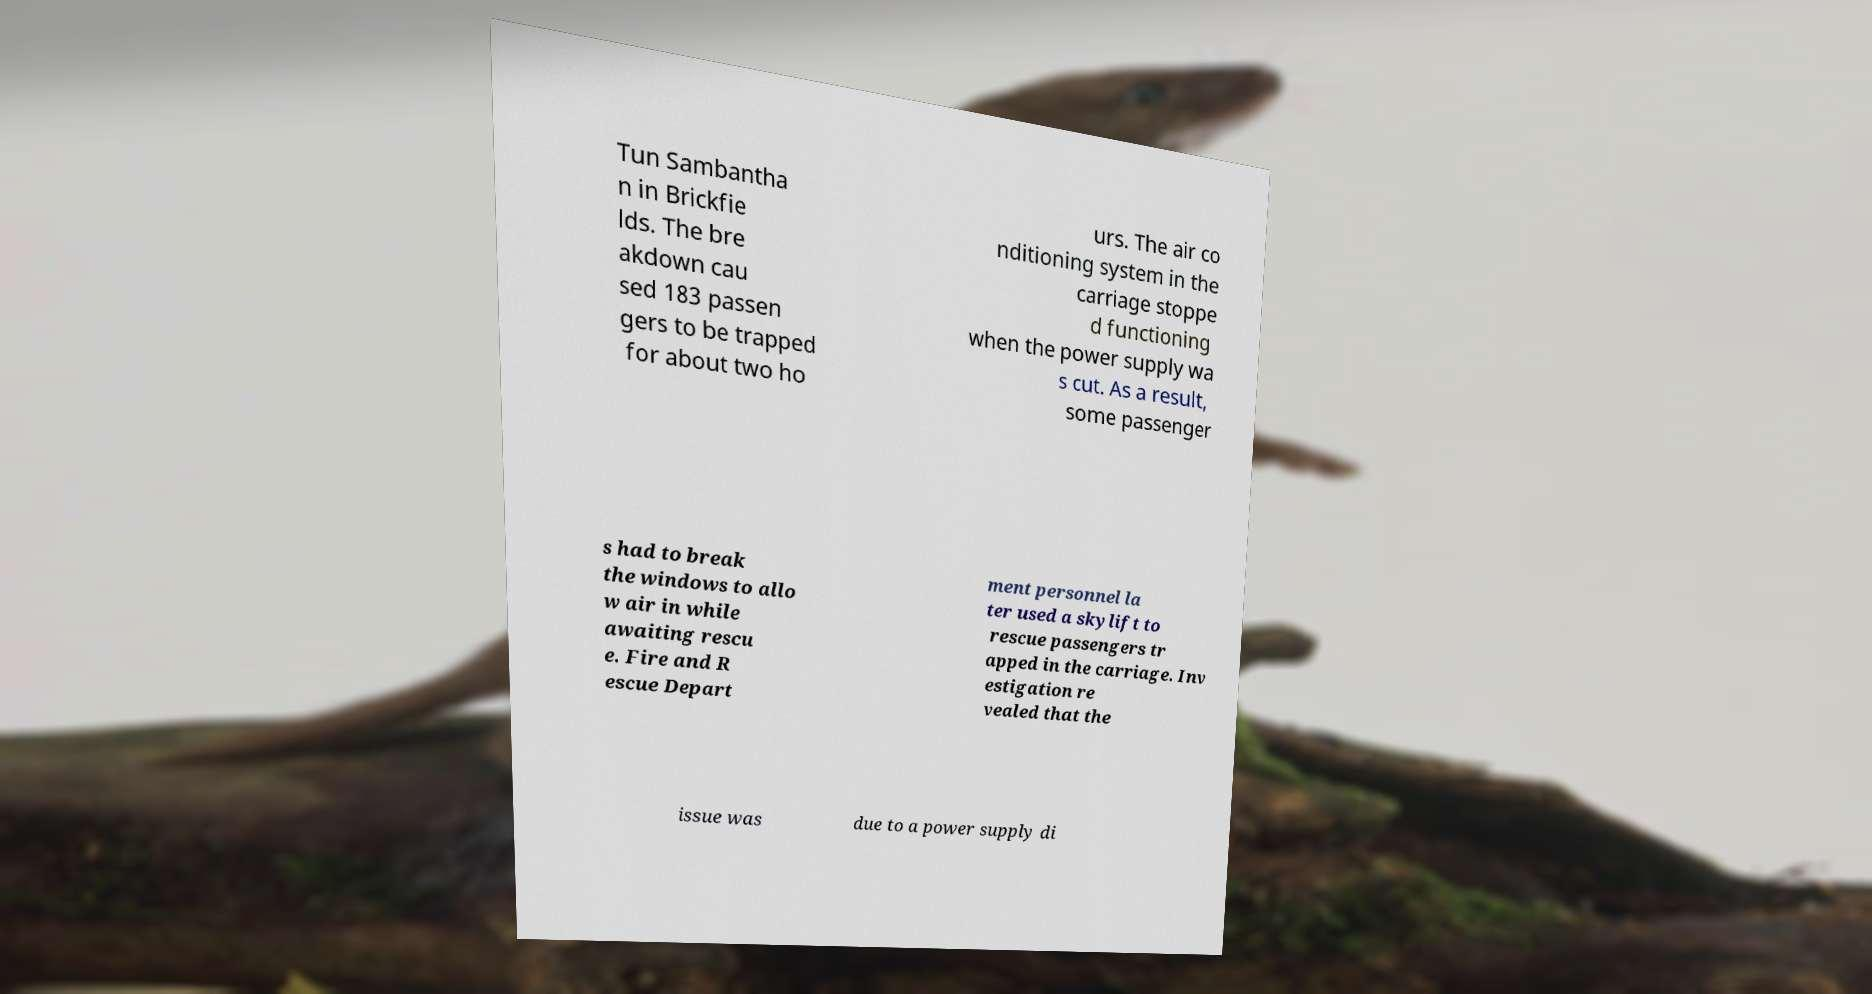Please read and relay the text visible in this image. What does it say? Tun Sambantha n in Brickfie lds. The bre akdown cau sed 183 passen gers to be trapped for about two ho urs. The air co nditioning system in the carriage stoppe d functioning when the power supply wa s cut. As a result, some passenger s had to break the windows to allo w air in while awaiting rescu e. Fire and R escue Depart ment personnel la ter used a skylift to rescue passengers tr apped in the carriage. Inv estigation re vealed that the issue was due to a power supply di 